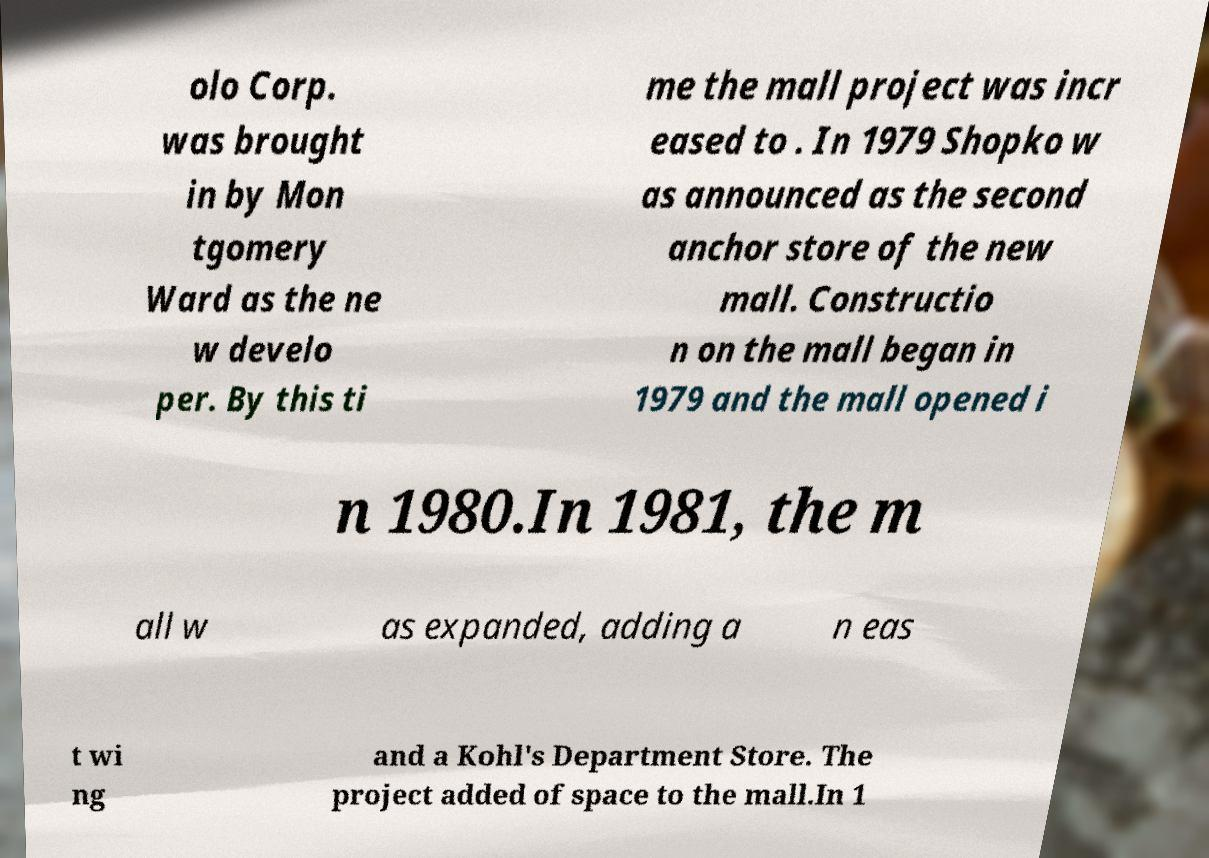For documentation purposes, I need the text within this image transcribed. Could you provide that? olo Corp. was brought in by Mon tgomery Ward as the ne w develo per. By this ti me the mall project was incr eased to . In 1979 Shopko w as announced as the second anchor store of the new mall. Constructio n on the mall began in 1979 and the mall opened i n 1980.In 1981, the m all w as expanded, adding a n eas t wi ng and a Kohl's Department Store. The project added of space to the mall.In 1 